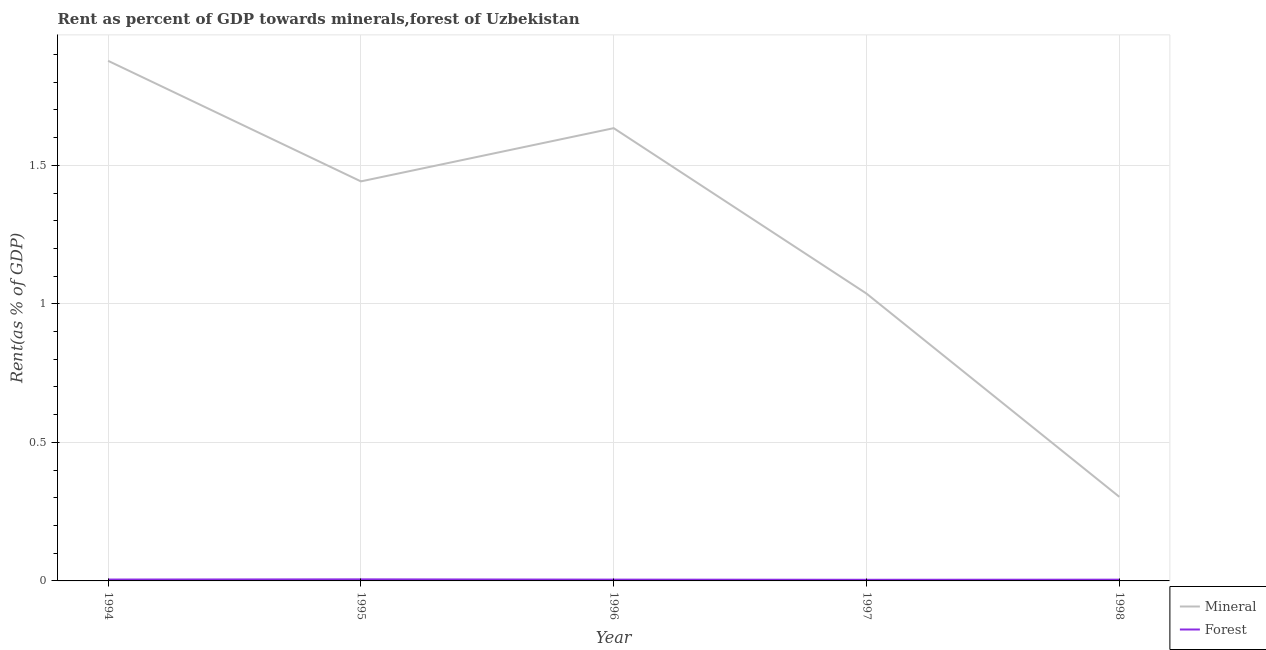What is the forest rent in 1997?
Your answer should be compact. 0. Across all years, what is the maximum forest rent?
Keep it short and to the point. 0.01. Across all years, what is the minimum mineral rent?
Your response must be concise. 0.3. In which year was the forest rent minimum?
Offer a very short reply. 1997. What is the total forest rent in the graph?
Offer a terse response. 0.02. What is the difference between the forest rent in 1994 and that in 1996?
Give a very brief answer. 0. What is the difference between the mineral rent in 1996 and the forest rent in 1995?
Provide a succinct answer. 1.63. What is the average forest rent per year?
Provide a succinct answer. 0. In the year 1997, what is the difference between the mineral rent and forest rent?
Offer a terse response. 1.03. In how many years, is the forest rent greater than 0.2 %?
Provide a succinct answer. 0. What is the ratio of the mineral rent in 1994 to that in 1996?
Give a very brief answer. 1.15. Is the difference between the mineral rent in 1995 and 1997 greater than the difference between the forest rent in 1995 and 1997?
Keep it short and to the point. Yes. What is the difference between the highest and the second highest mineral rent?
Keep it short and to the point. 0.24. What is the difference between the highest and the lowest mineral rent?
Ensure brevity in your answer.  1.57. Is the sum of the forest rent in 1996 and 1997 greater than the maximum mineral rent across all years?
Your answer should be compact. No. Does the forest rent monotonically increase over the years?
Offer a very short reply. No. Is the mineral rent strictly greater than the forest rent over the years?
Provide a succinct answer. Yes. Are the values on the major ticks of Y-axis written in scientific E-notation?
Offer a very short reply. No. Does the graph contain any zero values?
Make the answer very short. No. Where does the legend appear in the graph?
Your answer should be compact. Bottom right. How are the legend labels stacked?
Give a very brief answer. Vertical. What is the title of the graph?
Ensure brevity in your answer.  Rent as percent of GDP towards minerals,forest of Uzbekistan. What is the label or title of the X-axis?
Offer a terse response. Year. What is the label or title of the Y-axis?
Make the answer very short. Rent(as % of GDP). What is the Rent(as % of GDP) of Mineral in 1994?
Give a very brief answer. 1.88. What is the Rent(as % of GDP) in Forest in 1994?
Keep it short and to the point. 0. What is the Rent(as % of GDP) in Mineral in 1995?
Keep it short and to the point. 1.44. What is the Rent(as % of GDP) of Forest in 1995?
Your answer should be very brief. 0.01. What is the Rent(as % of GDP) of Mineral in 1996?
Offer a terse response. 1.63. What is the Rent(as % of GDP) in Forest in 1996?
Your response must be concise. 0. What is the Rent(as % of GDP) in Mineral in 1997?
Offer a terse response. 1.04. What is the Rent(as % of GDP) in Forest in 1997?
Your answer should be very brief. 0. What is the Rent(as % of GDP) in Mineral in 1998?
Give a very brief answer. 0.3. What is the Rent(as % of GDP) of Forest in 1998?
Your answer should be compact. 0. Across all years, what is the maximum Rent(as % of GDP) in Mineral?
Offer a terse response. 1.88. Across all years, what is the maximum Rent(as % of GDP) in Forest?
Your answer should be very brief. 0.01. Across all years, what is the minimum Rent(as % of GDP) in Mineral?
Your answer should be very brief. 0.3. Across all years, what is the minimum Rent(as % of GDP) of Forest?
Provide a succinct answer. 0. What is the total Rent(as % of GDP) of Mineral in the graph?
Give a very brief answer. 6.29. What is the total Rent(as % of GDP) of Forest in the graph?
Provide a succinct answer. 0.02. What is the difference between the Rent(as % of GDP) in Mineral in 1994 and that in 1995?
Your response must be concise. 0.44. What is the difference between the Rent(as % of GDP) in Forest in 1994 and that in 1995?
Make the answer very short. -0. What is the difference between the Rent(as % of GDP) in Mineral in 1994 and that in 1996?
Provide a succinct answer. 0.24. What is the difference between the Rent(as % of GDP) of Forest in 1994 and that in 1996?
Provide a short and direct response. 0. What is the difference between the Rent(as % of GDP) in Mineral in 1994 and that in 1997?
Keep it short and to the point. 0.84. What is the difference between the Rent(as % of GDP) of Forest in 1994 and that in 1997?
Make the answer very short. 0. What is the difference between the Rent(as % of GDP) in Mineral in 1994 and that in 1998?
Offer a terse response. 1.57. What is the difference between the Rent(as % of GDP) of Forest in 1994 and that in 1998?
Offer a very short reply. 0. What is the difference between the Rent(as % of GDP) in Mineral in 1995 and that in 1996?
Your answer should be very brief. -0.19. What is the difference between the Rent(as % of GDP) in Forest in 1995 and that in 1996?
Your response must be concise. 0. What is the difference between the Rent(as % of GDP) of Mineral in 1995 and that in 1997?
Keep it short and to the point. 0.4. What is the difference between the Rent(as % of GDP) in Forest in 1995 and that in 1997?
Offer a terse response. 0. What is the difference between the Rent(as % of GDP) of Mineral in 1995 and that in 1998?
Your answer should be compact. 1.14. What is the difference between the Rent(as % of GDP) of Forest in 1995 and that in 1998?
Offer a very short reply. 0. What is the difference between the Rent(as % of GDP) of Mineral in 1996 and that in 1997?
Offer a very short reply. 0.6. What is the difference between the Rent(as % of GDP) of Forest in 1996 and that in 1997?
Your response must be concise. 0. What is the difference between the Rent(as % of GDP) of Mineral in 1996 and that in 1998?
Your answer should be compact. 1.33. What is the difference between the Rent(as % of GDP) of Forest in 1996 and that in 1998?
Your answer should be compact. 0. What is the difference between the Rent(as % of GDP) of Mineral in 1997 and that in 1998?
Offer a very short reply. 0.73. What is the difference between the Rent(as % of GDP) of Forest in 1997 and that in 1998?
Offer a terse response. -0. What is the difference between the Rent(as % of GDP) in Mineral in 1994 and the Rent(as % of GDP) in Forest in 1995?
Your response must be concise. 1.87. What is the difference between the Rent(as % of GDP) in Mineral in 1994 and the Rent(as % of GDP) in Forest in 1996?
Your response must be concise. 1.87. What is the difference between the Rent(as % of GDP) of Mineral in 1994 and the Rent(as % of GDP) of Forest in 1997?
Your response must be concise. 1.87. What is the difference between the Rent(as % of GDP) in Mineral in 1994 and the Rent(as % of GDP) in Forest in 1998?
Offer a very short reply. 1.87. What is the difference between the Rent(as % of GDP) of Mineral in 1995 and the Rent(as % of GDP) of Forest in 1996?
Keep it short and to the point. 1.44. What is the difference between the Rent(as % of GDP) in Mineral in 1995 and the Rent(as % of GDP) in Forest in 1997?
Your answer should be compact. 1.44. What is the difference between the Rent(as % of GDP) in Mineral in 1995 and the Rent(as % of GDP) in Forest in 1998?
Your response must be concise. 1.44. What is the difference between the Rent(as % of GDP) in Mineral in 1996 and the Rent(as % of GDP) in Forest in 1997?
Your answer should be very brief. 1.63. What is the difference between the Rent(as % of GDP) of Mineral in 1996 and the Rent(as % of GDP) of Forest in 1998?
Your answer should be compact. 1.63. What is the difference between the Rent(as % of GDP) of Mineral in 1997 and the Rent(as % of GDP) of Forest in 1998?
Your response must be concise. 1.03. What is the average Rent(as % of GDP) of Mineral per year?
Your answer should be compact. 1.26. What is the average Rent(as % of GDP) in Forest per year?
Provide a succinct answer. 0. In the year 1994, what is the difference between the Rent(as % of GDP) of Mineral and Rent(as % of GDP) of Forest?
Give a very brief answer. 1.87. In the year 1995, what is the difference between the Rent(as % of GDP) in Mineral and Rent(as % of GDP) in Forest?
Make the answer very short. 1.44. In the year 1996, what is the difference between the Rent(as % of GDP) of Mineral and Rent(as % of GDP) of Forest?
Your response must be concise. 1.63. In the year 1997, what is the difference between the Rent(as % of GDP) in Mineral and Rent(as % of GDP) in Forest?
Your response must be concise. 1.03. In the year 1998, what is the difference between the Rent(as % of GDP) of Mineral and Rent(as % of GDP) of Forest?
Your answer should be compact. 0.3. What is the ratio of the Rent(as % of GDP) in Mineral in 1994 to that in 1995?
Keep it short and to the point. 1.3. What is the ratio of the Rent(as % of GDP) in Forest in 1994 to that in 1995?
Provide a succinct answer. 0.87. What is the ratio of the Rent(as % of GDP) in Mineral in 1994 to that in 1996?
Your response must be concise. 1.15. What is the ratio of the Rent(as % of GDP) in Forest in 1994 to that in 1996?
Give a very brief answer. 1.06. What is the ratio of the Rent(as % of GDP) of Mineral in 1994 to that in 1997?
Your response must be concise. 1.81. What is the ratio of the Rent(as % of GDP) of Forest in 1994 to that in 1997?
Your answer should be very brief. 1.2. What is the ratio of the Rent(as % of GDP) of Mineral in 1994 to that in 1998?
Offer a very short reply. 6.19. What is the ratio of the Rent(as % of GDP) in Forest in 1994 to that in 1998?
Keep it short and to the point. 1.1. What is the ratio of the Rent(as % of GDP) of Mineral in 1995 to that in 1996?
Your response must be concise. 0.88. What is the ratio of the Rent(as % of GDP) in Forest in 1995 to that in 1996?
Give a very brief answer. 1.21. What is the ratio of the Rent(as % of GDP) of Mineral in 1995 to that in 1997?
Your answer should be very brief. 1.39. What is the ratio of the Rent(as % of GDP) in Forest in 1995 to that in 1997?
Give a very brief answer. 1.37. What is the ratio of the Rent(as % of GDP) in Mineral in 1995 to that in 1998?
Give a very brief answer. 4.75. What is the ratio of the Rent(as % of GDP) of Forest in 1995 to that in 1998?
Your answer should be very brief. 1.25. What is the ratio of the Rent(as % of GDP) of Mineral in 1996 to that in 1997?
Your response must be concise. 1.58. What is the ratio of the Rent(as % of GDP) in Forest in 1996 to that in 1997?
Your answer should be very brief. 1.13. What is the ratio of the Rent(as % of GDP) of Mineral in 1996 to that in 1998?
Keep it short and to the point. 5.39. What is the ratio of the Rent(as % of GDP) of Forest in 1996 to that in 1998?
Ensure brevity in your answer.  1.03. What is the ratio of the Rent(as % of GDP) of Mineral in 1997 to that in 1998?
Offer a very short reply. 3.42. What is the ratio of the Rent(as % of GDP) in Forest in 1997 to that in 1998?
Provide a succinct answer. 0.91. What is the difference between the highest and the second highest Rent(as % of GDP) of Mineral?
Ensure brevity in your answer.  0.24. What is the difference between the highest and the second highest Rent(as % of GDP) of Forest?
Your answer should be very brief. 0. What is the difference between the highest and the lowest Rent(as % of GDP) in Mineral?
Ensure brevity in your answer.  1.57. What is the difference between the highest and the lowest Rent(as % of GDP) of Forest?
Offer a very short reply. 0. 